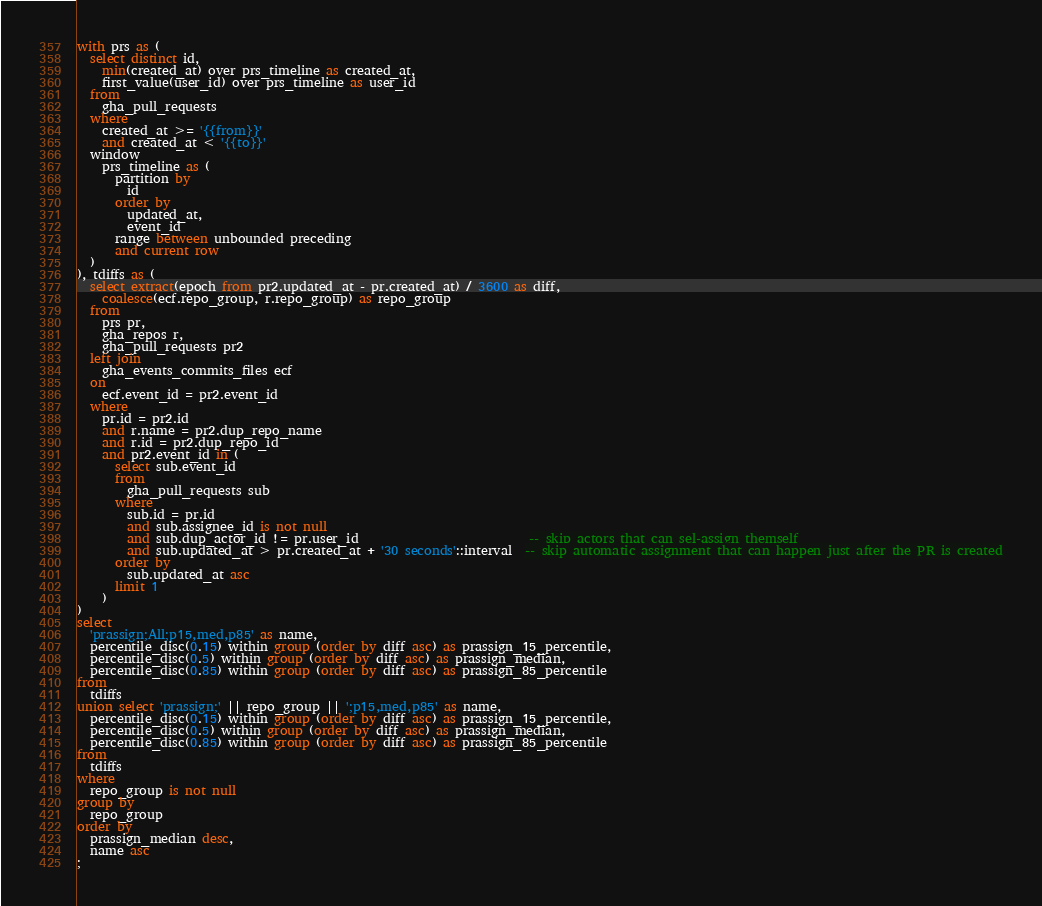Convert code to text. <code><loc_0><loc_0><loc_500><loc_500><_SQL_>with prs as (
  select distinct id,
    min(created_at) over prs_timeline as created_at,
    first_value(user_id) over prs_timeline as user_id
  from
    gha_pull_requests
  where
    created_at >= '{{from}}'
    and created_at < '{{to}}'
  window
    prs_timeline as (
      partition by
        id
      order by
        updated_at,
        event_id
      range between unbounded preceding
      and current row
  )
), tdiffs as (
  select extract(epoch from pr2.updated_at - pr.created_at) / 3600 as diff,
    coalesce(ecf.repo_group, r.repo_group) as repo_group
  from
    prs pr,
    gha_repos r,
    gha_pull_requests pr2
  left join
    gha_events_commits_files ecf
  on
    ecf.event_id = pr2.event_id
  where
    pr.id = pr2.id
    and r.name = pr2.dup_repo_name
    and r.id = pr2.dup_repo_id
    and pr2.event_id in (
      select sub.event_id
      from
        gha_pull_requests sub
      where
        sub.id = pr.id
        and sub.assignee_id is not null
        and sub.dup_actor_id != pr.user_id                           -- skip actors that can sel-assign themself
        and sub.updated_at > pr.created_at + '30 seconds'::interval  -- skip automatic assignment that can happen just after the PR is created
      order by
        sub.updated_at asc
      limit 1
    )
)
select
  'prassign;All;p15,med,p85' as name,
  percentile_disc(0.15) within group (order by diff asc) as prassign_15_percentile,
  percentile_disc(0.5) within group (order by diff asc) as prassign_median,
  percentile_disc(0.85) within group (order by diff asc) as prassign_85_percentile
from
  tdiffs
union select 'prassign;' || repo_group || ';p15,med,p85' as name,
  percentile_disc(0.15) within group (order by diff asc) as prassign_15_percentile,
  percentile_disc(0.5) within group (order by diff asc) as prassign_median,
  percentile_disc(0.85) within group (order by diff asc) as prassign_85_percentile
from
  tdiffs
where
  repo_group is not null
group by
  repo_group
order by
  prassign_median desc,
  name asc
;
</code> 